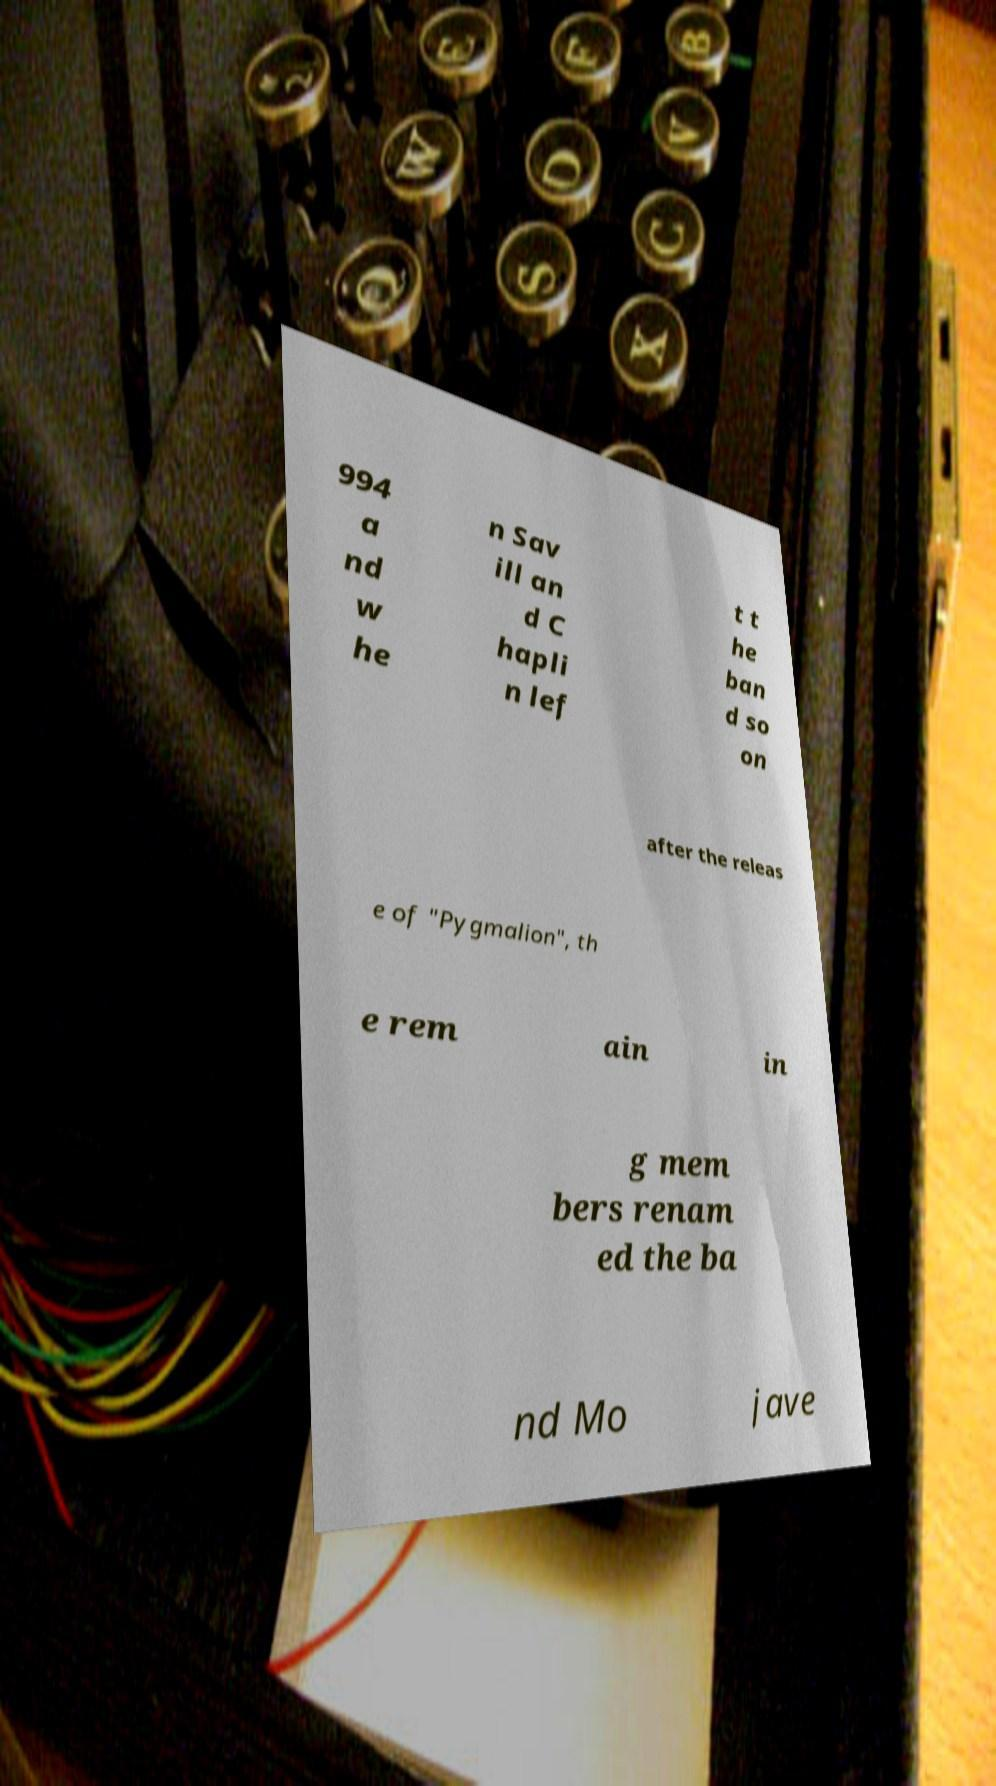Please identify and transcribe the text found in this image. 994 a nd w he n Sav ill an d C hapli n lef t t he ban d so on after the releas e of "Pygmalion", th e rem ain in g mem bers renam ed the ba nd Mo jave 